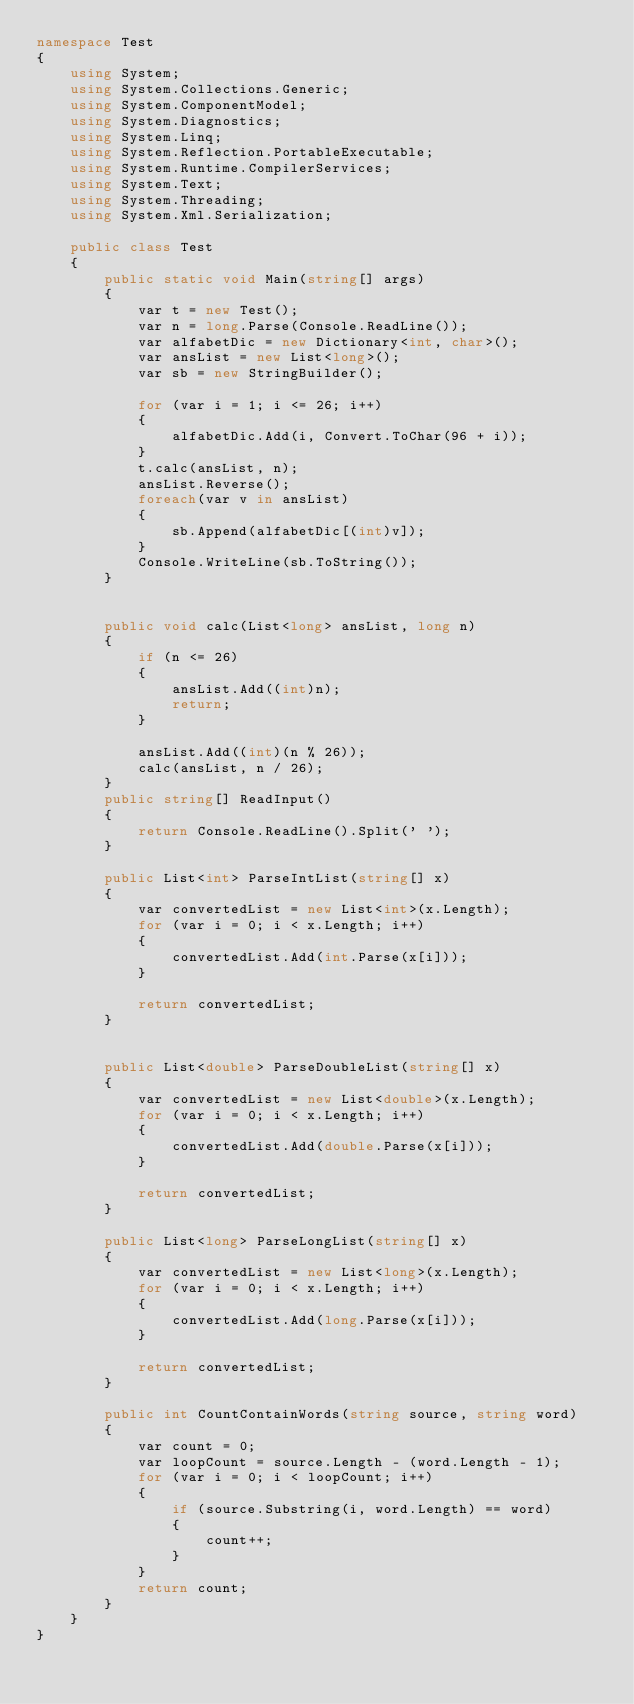Convert code to text. <code><loc_0><loc_0><loc_500><loc_500><_C#_>namespace Test
{
    using System;
    using System.Collections.Generic;
    using System.ComponentModel;
    using System.Diagnostics;
    using System.Linq;
    using System.Reflection.PortableExecutable;
    using System.Runtime.CompilerServices;
    using System.Text;
    using System.Threading;
    using System.Xml.Serialization;

    public class Test
    {
        public static void Main(string[] args)
        {
            var t = new Test();
            var n = long.Parse(Console.ReadLine());
            var alfabetDic = new Dictionary<int, char>();
            var ansList = new List<long>();
            var sb = new StringBuilder();

            for (var i = 1; i <= 26; i++)
            {
                alfabetDic.Add(i, Convert.ToChar(96 + i));
            }
            t.calc(ansList, n);
            ansList.Reverse();
            foreach(var v in ansList)
            {
                sb.Append(alfabetDic[(int)v]);
            }
            Console.WriteLine(sb.ToString()); 
        }


        public void calc(List<long> ansList, long n)
        {
            if (n <= 26)
            {
                ansList.Add((int)n);
                return;
            }
            
            ansList.Add((int)(n % 26));
            calc(ansList, n / 26);
        }
        public string[] ReadInput()
        {
            return Console.ReadLine().Split(' ');
        }

        public List<int> ParseIntList(string[] x)
        {
            var convertedList = new List<int>(x.Length);
            for (var i = 0; i < x.Length; i++)
            {
                convertedList.Add(int.Parse(x[i]));
            }

            return convertedList;
        }


        public List<double> ParseDoubleList(string[] x)
        {
            var convertedList = new List<double>(x.Length);
            for (var i = 0; i < x.Length; i++)
            {
                convertedList.Add(double.Parse(x[i]));
            }

            return convertedList;
        }

        public List<long> ParseLongList(string[] x)
        {
            var convertedList = new List<long>(x.Length);
            for (var i = 0; i < x.Length; i++)
            {
                convertedList.Add(long.Parse(x[i]));
            }

            return convertedList;
        }

        public int CountContainWords(string source, string word)
        {
            var count = 0;
            var loopCount = source.Length - (word.Length - 1);
            for (var i = 0; i < loopCount; i++)
            {
                if (source.Substring(i, word.Length) == word)
                {
                    count++;
                }
            }
            return count;
        }
    }
}</code> 